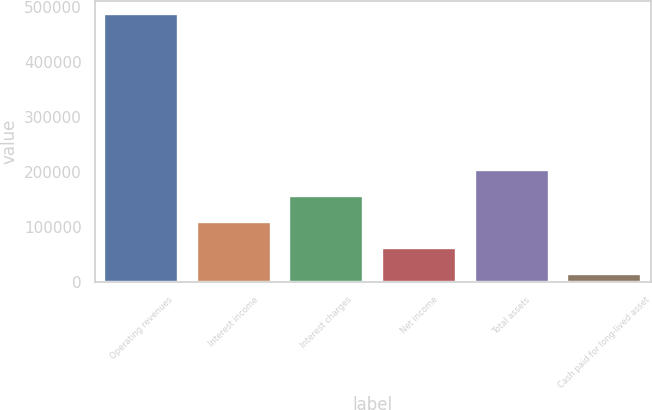<chart> <loc_0><loc_0><loc_500><loc_500><bar_chart><fcel>Operating revenues<fcel>Interest income<fcel>Interest charges<fcel>Net income<fcel>Total assets<fcel>Cash paid for long-lived asset<nl><fcel>486804<fcel>108244<fcel>155564<fcel>60924<fcel>202884<fcel>13604<nl></chart> 